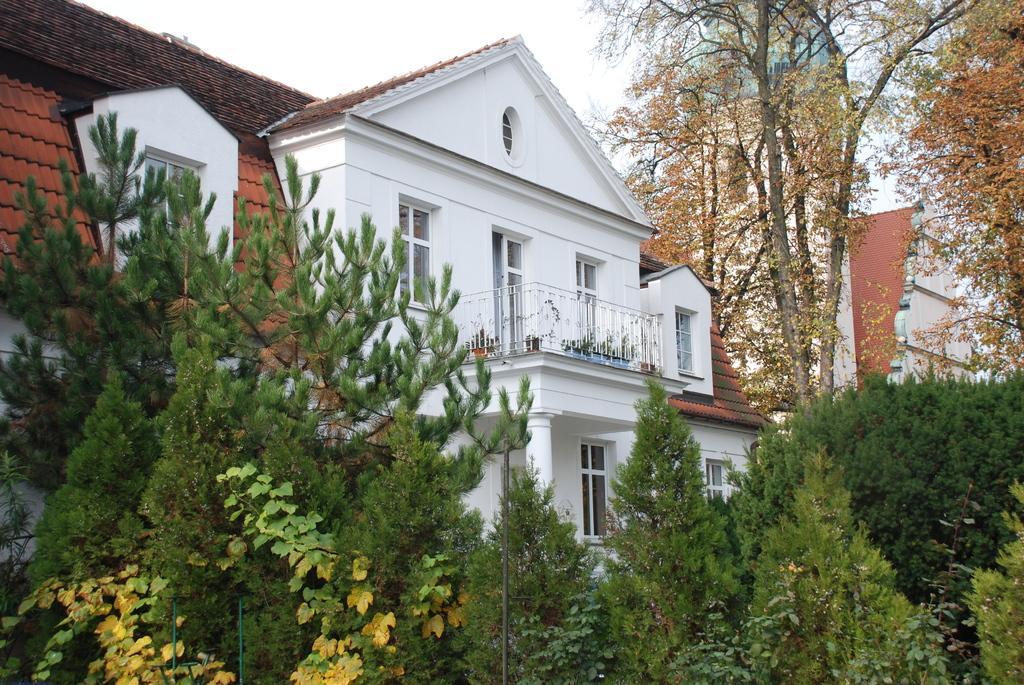How would you summarize this image in a sentence or two? In this image we can see buildings, houseplants, grill, sky, trees, poles and bushes. 